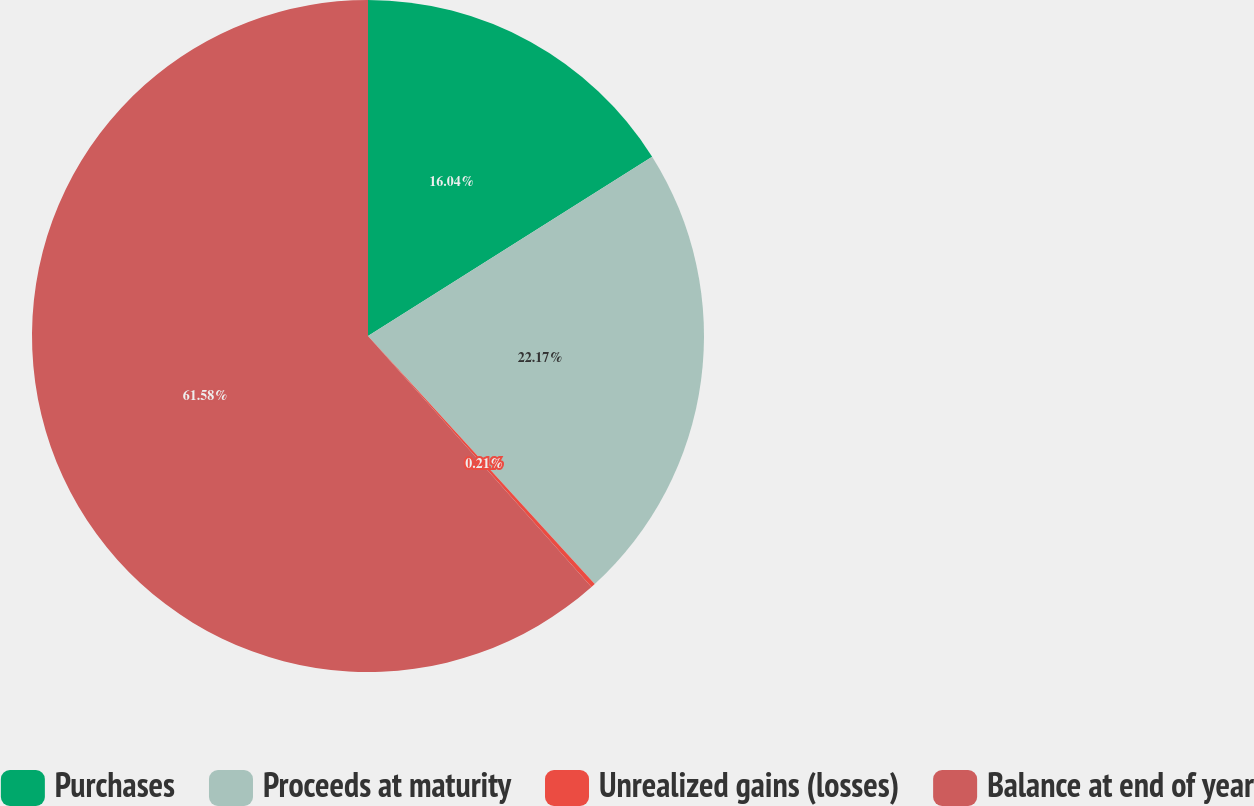Convert chart to OTSL. <chart><loc_0><loc_0><loc_500><loc_500><pie_chart><fcel>Purchases<fcel>Proceeds at maturity<fcel>Unrealized gains (losses)<fcel>Balance at end of year<nl><fcel>16.04%<fcel>22.17%<fcel>0.21%<fcel>61.58%<nl></chart> 